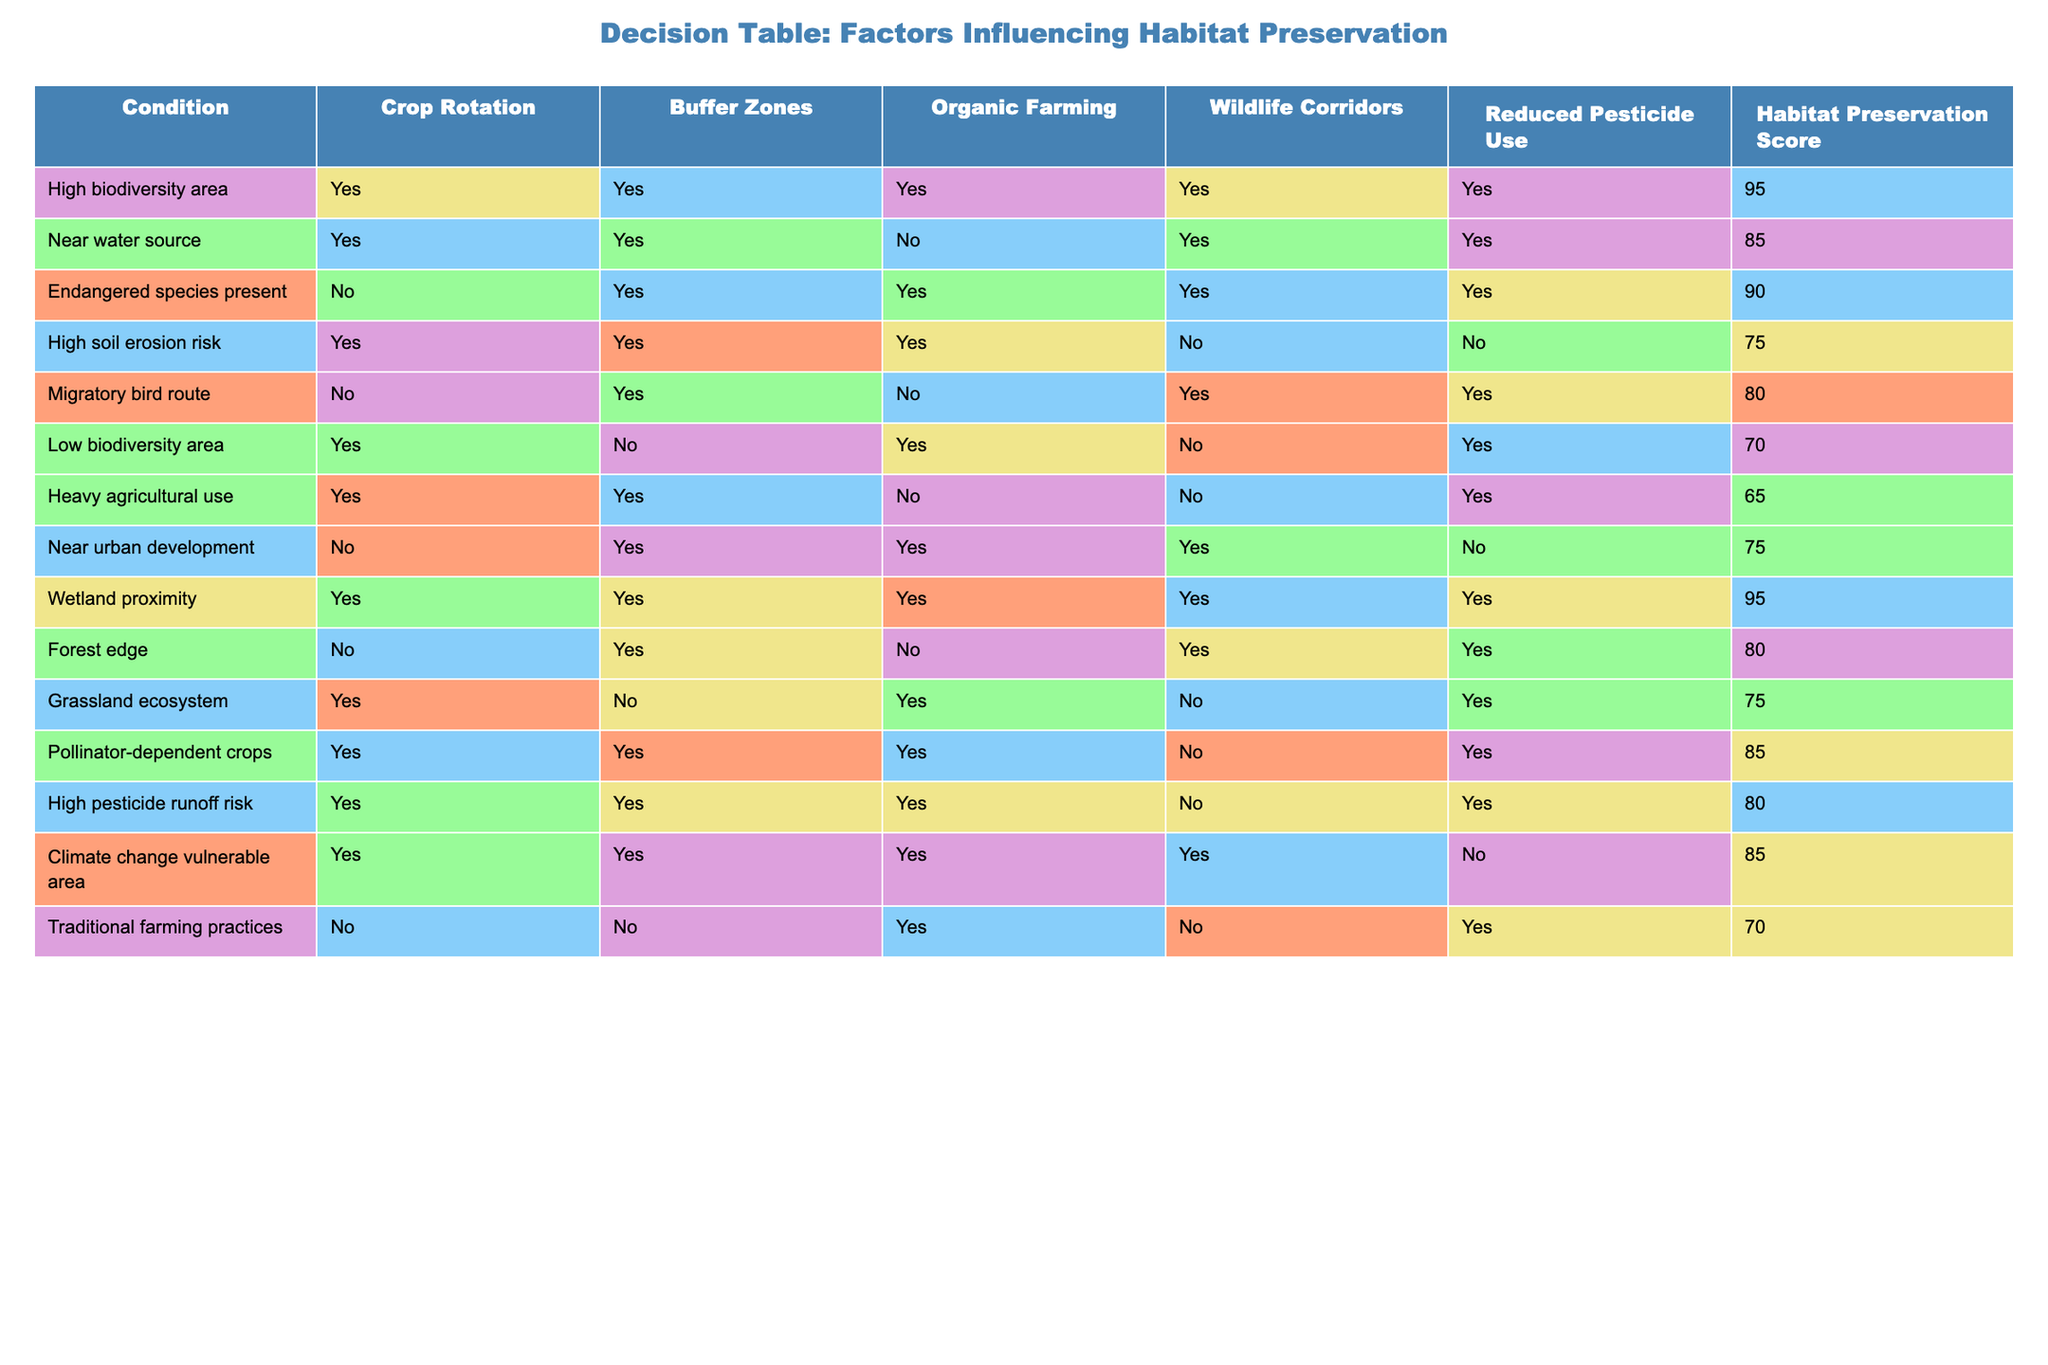What is the habitat preservation score for high biodiversity areas? The habitat preservation score is a specific value associated with the condition of high biodiversity areas. Looking at the table, the row for high biodiversity areas states that the habitat preservation score is 95.
Answer: 95 How many conditions have a habitat preservation score of 80 or higher? To determine this, we need to count the rows with a score of 80 or above. The conditions with scores of 80 or higher are: high biodiversity area (95), wetland proximity (95), endangered species present (90), migratory bird route (80), forest edge (80), and high pesticide runoff risk (80). This gives us a total of 6 conditions.
Answer: 6 Is organic farming implemented in a condition with high soil erosion risk? The table shows that the condition "high soil erosion risk" has a value of "No" under organic farming. This means organic farming is not implemented in this particular condition.
Answer: No What is the difference in habitat preservation scores between areas near water sources and those in low biodiversity areas? To find the difference in scores, we look at the corresponding values. The score for near water sources is 85, and the score for low biodiversity areas is 70. The difference is calculated as 85 - 70 = 15.
Answer: 15 Do wildlife corridors exist in areas that have heavy agricultural use? Checking the row for the condition "heavy agricultural use," it shows "No" for wildlife corridors. Therefore, wildlife corridors do not exist in areas classified in this way.
Answer: No What is the average habitat preservation score for conditions where there is a use of reduced pesticide? We will sum the relevant habitat preservation scores for conditions that use reduced pesticide: high biodiversity area (95), near water source (85), endangered species present (90), low biodiversity area (70), heavy agricultural use (65), and high pesticide runoff risk (80). Adding these gives 95 + 85 + 90 + 70 + 65 + 80 = 485. There are 6 conditions, thus the average is 485 / 6 = approximately 80.83.
Answer: 80.83 Which condition has the highest habitat preservation score and what practices contribute to it? The condition with the highest habitat preservation score is "high biodiversity area" with a score of 95. The practices contributing to this score are crop rotation, buffer zones, organic farming, wildlife corridors, and reduced pesticide use, all marked "Yes."
Answer: High biodiversity area, 95 How many of the conditions listed implement both buffer zones and organic farming? We need to find the rows where both "Yes" is marked for buffer zones and organic farming. By checking the table, the conditions meeting this criteria are: high biodiversity area, near water source, endangered species present, high soil erosion risk, pollinator-dependent crops, and climate change vulnerable area. That results in a total of 6 conditions.
Answer: 6 